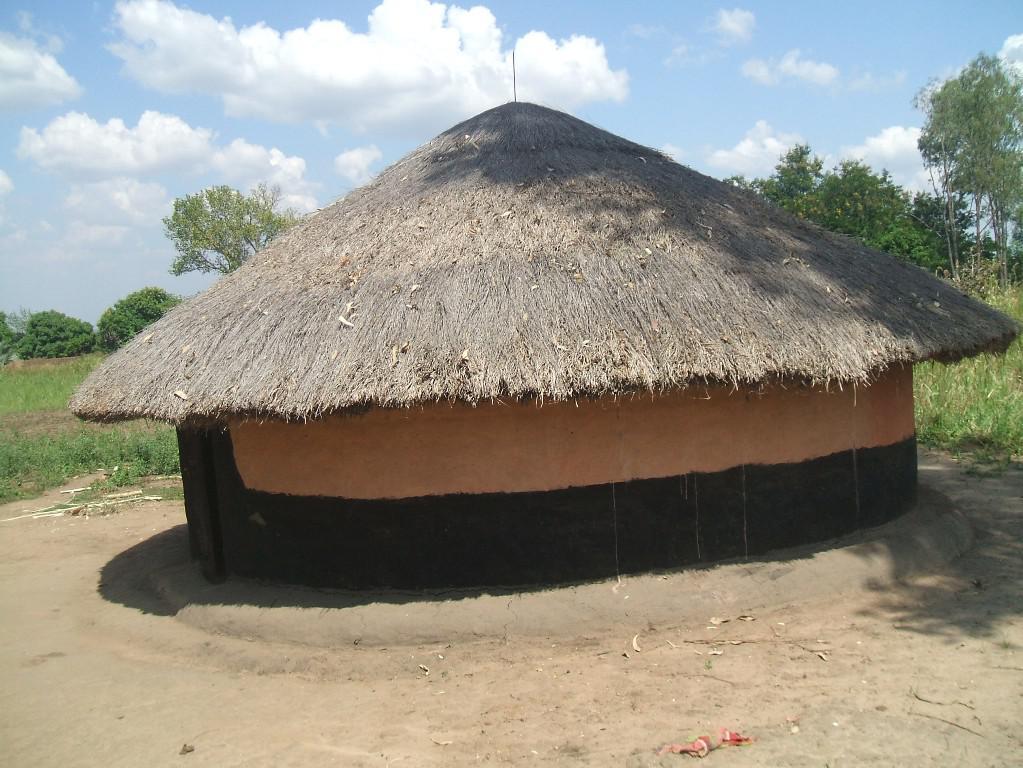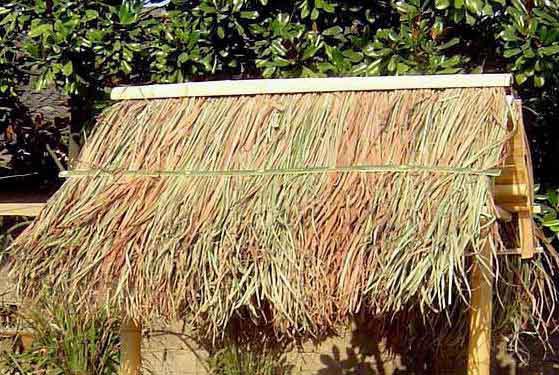The first image is the image on the left, the second image is the image on the right. Evaluate the accuracy of this statement regarding the images: "A round hut with a round grass roof can be seen.". Is it true? Answer yes or no. Yes. The first image is the image on the left, the second image is the image on the right. Given the left and right images, does the statement "One image shows a structure with at least one peaked roof held up by beams and with open sides, in front of a body of water" hold true? Answer yes or no. No. 